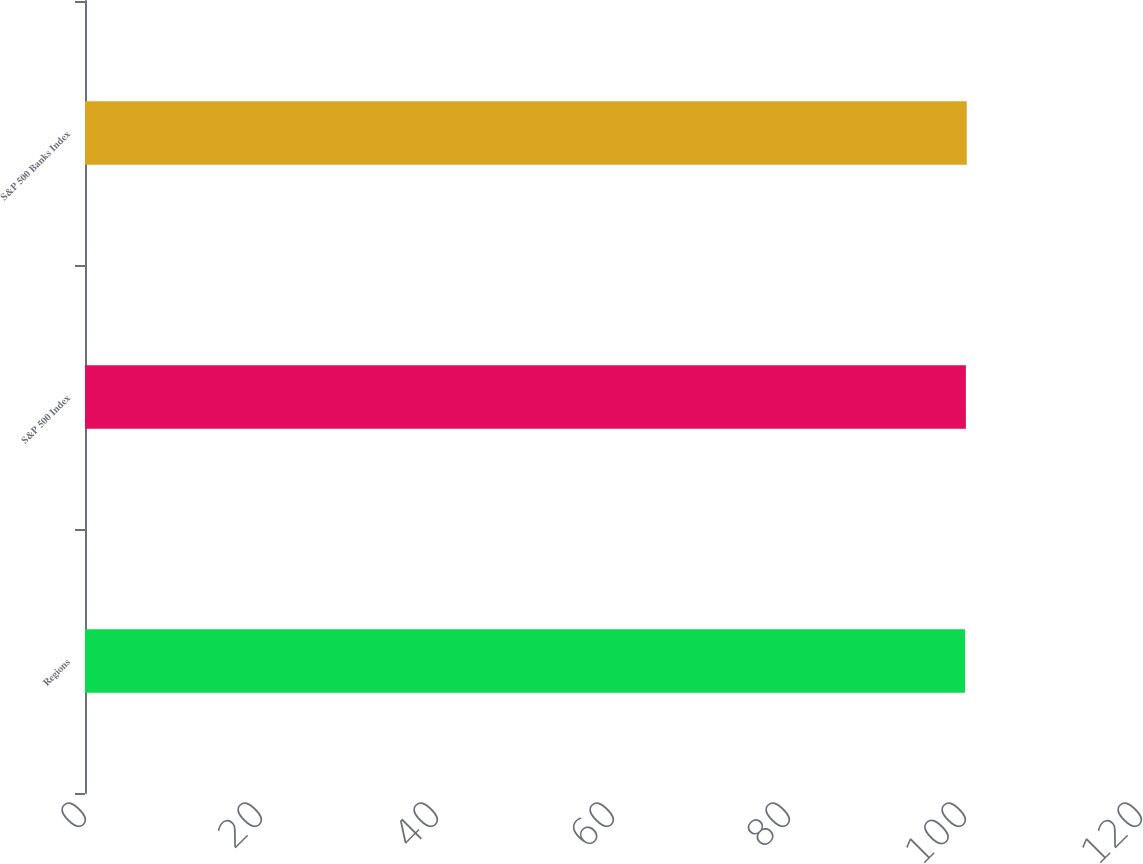<chart> <loc_0><loc_0><loc_500><loc_500><bar_chart><fcel>Regions<fcel>S&P 500 Index<fcel>S&P 500 Banks Index<nl><fcel>100<fcel>100.1<fcel>100.2<nl></chart> 